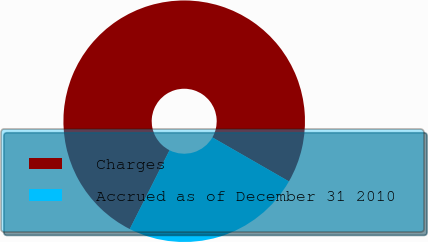<chart> <loc_0><loc_0><loc_500><loc_500><pie_chart><fcel>Charges<fcel>Accrued as of December 31 2010<nl><fcel>75.86%<fcel>24.14%<nl></chart> 